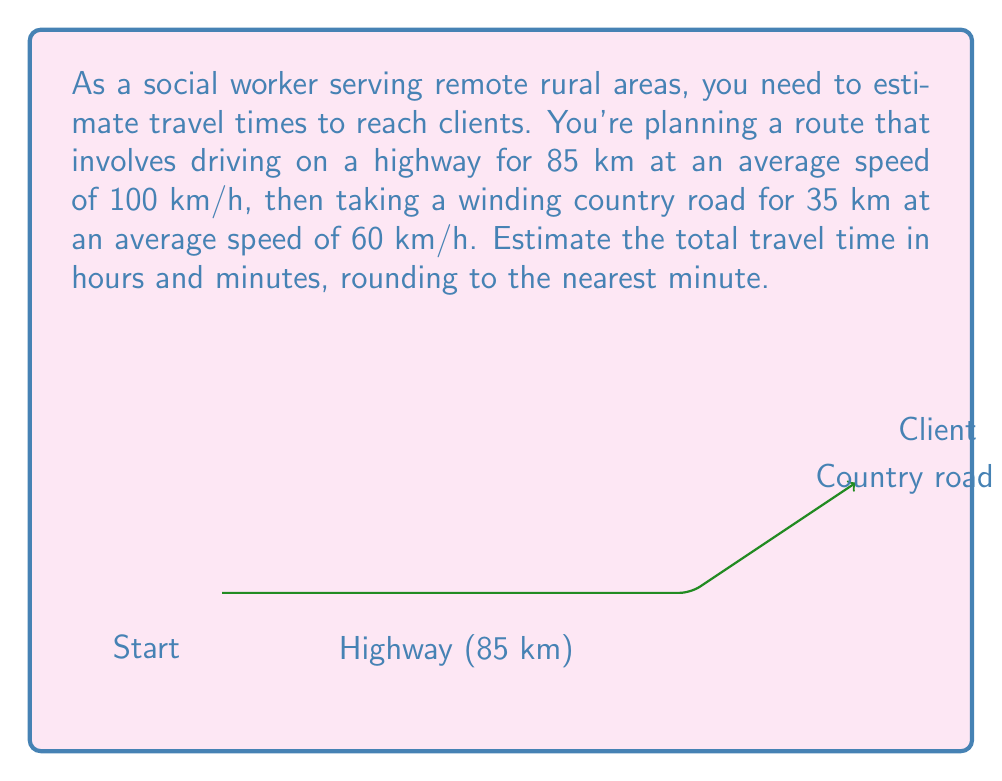Provide a solution to this math problem. Let's break this down step-by-step:

1) First, calculate the time spent on the highway:
   Distance = 85 km, Speed = 100 km/h
   Time = Distance ÷ Speed
   $$T_{highway} = \frac{85}{100} = 0.85\text{ hours}$$

2) Next, calculate the time spent on the country road:
   Distance = 35 km, Speed = 60 km/h
   $$T_{country} = \frac{35}{60} = 0.5833...\text{ hours}$$

3) Sum up the total time:
   $$T_{total} = T_{highway} + T_{country} = 0.85 + 0.5833... = 1.4333...\text{ hours}$$

4) Convert the decimal hours to hours and minutes:
   0.4333... hours × 60 minutes/hour = 26 minutes

5) Rounding to the nearest minute:
   1 hour and 26 minutes

Therefore, the estimated total travel time is 1 hour and 26 minutes.
Answer: 1 hour and 26 minutes 